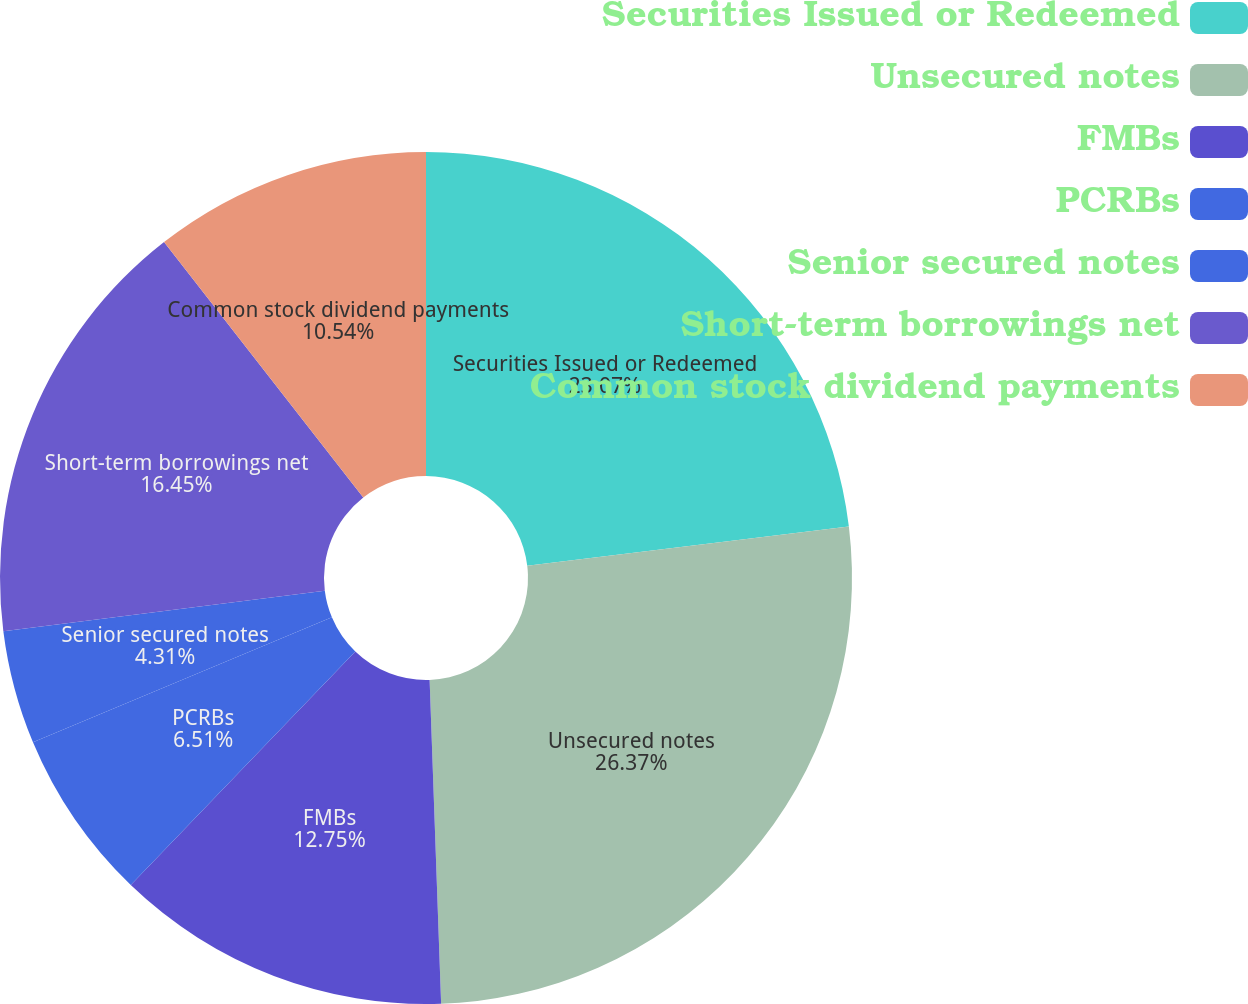Convert chart to OTSL. <chart><loc_0><loc_0><loc_500><loc_500><pie_chart><fcel>Securities Issued or Redeemed<fcel>Unsecured notes<fcel>FMBs<fcel>PCRBs<fcel>Senior secured notes<fcel>Short-­term borrowings net<fcel>Common stock dividend payments<nl><fcel>23.07%<fcel>26.36%<fcel>12.75%<fcel>6.51%<fcel>4.31%<fcel>16.45%<fcel>10.54%<nl></chart> 